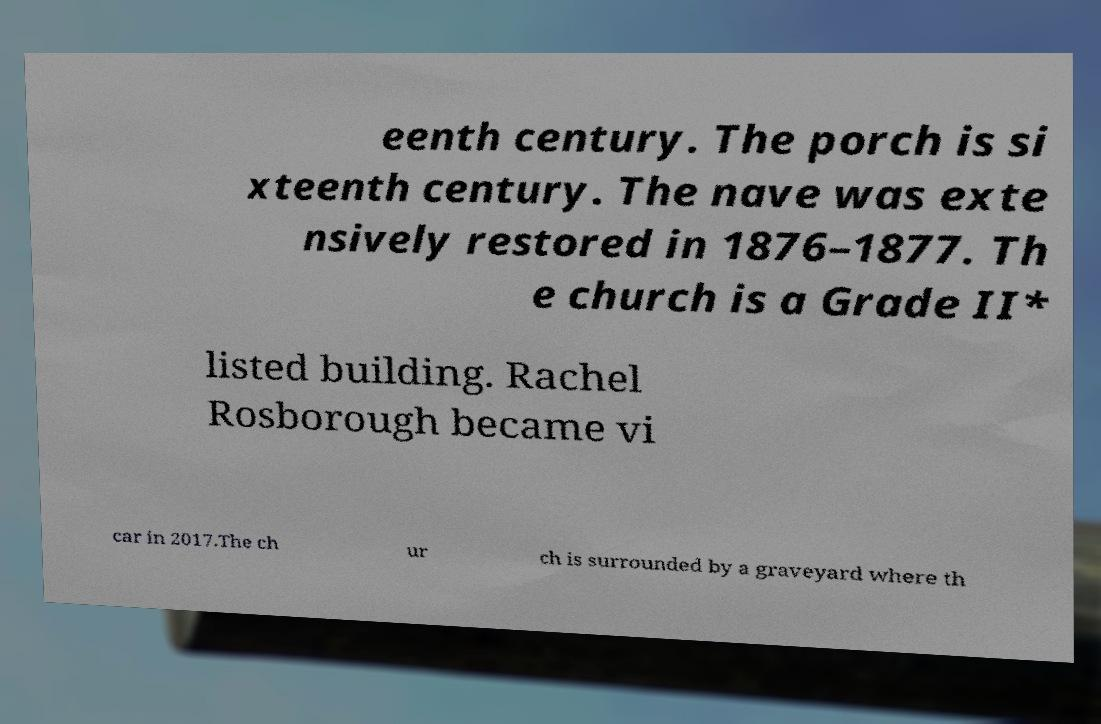Please read and relay the text visible in this image. What does it say? eenth century. The porch is si xteenth century. The nave was exte nsively restored in 1876–1877. Th e church is a Grade II* listed building. Rachel Rosborough became vi car in 2017.The ch ur ch is surrounded by a graveyard where th 